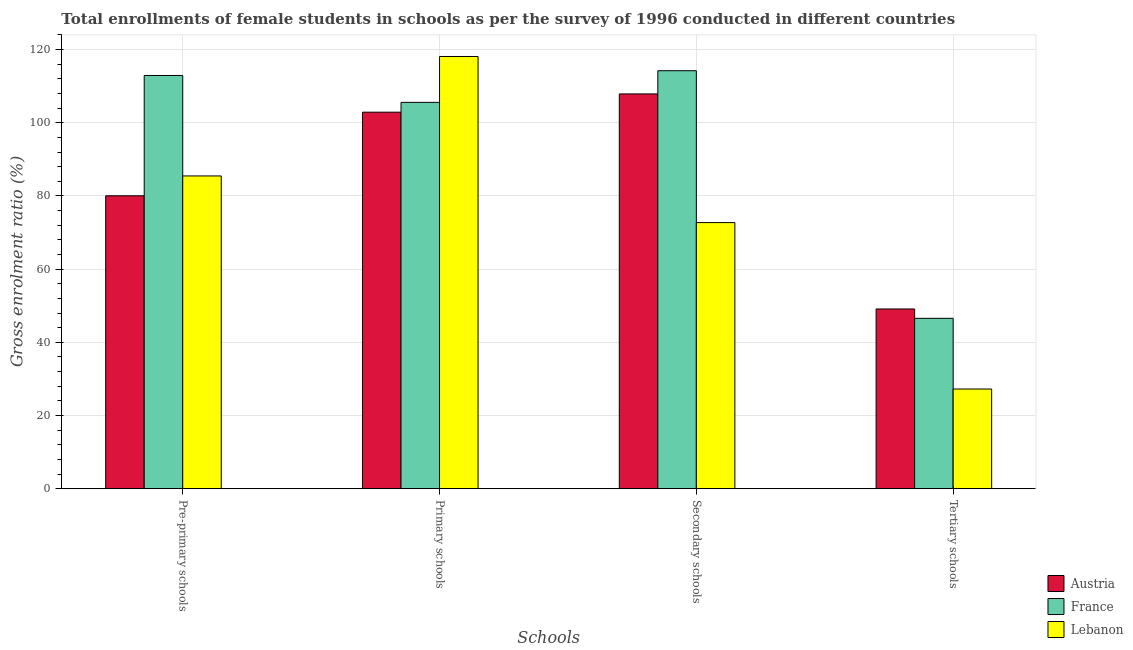How many different coloured bars are there?
Your answer should be compact. 3. What is the label of the 2nd group of bars from the left?
Provide a short and direct response. Primary schools. What is the gross enrolment ratio(female) in primary schools in France?
Offer a terse response. 105.58. Across all countries, what is the maximum gross enrolment ratio(female) in secondary schools?
Offer a terse response. 114.23. Across all countries, what is the minimum gross enrolment ratio(female) in secondary schools?
Your answer should be very brief. 72.72. In which country was the gross enrolment ratio(female) in tertiary schools minimum?
Keep it short and to the point. Lebanon. What is the total gross enrolment ratio(female) in tertiary schools in the graph?
Offer a terse response. 122.92. What is the difference between the gross enrolment ratio(female) in secondary schools in France and that in Lebanon?
Offer a terse response. 41.51. What is the difference between the gross enrolment ratio(female) in primary schools in Austria and the gross enrolment ratio(female) in secondary schools in France?
Provide a short and direct response. -11.33. What is the average gross enrolment ratio(female) in tertiary schools per country?
Offer a terse response. 40.97. What is the difference between the gross enrolment ratio(female) in secondary schools and gross enrolment ratio(female) in pre-primary schools in Lebanon?
Offer a very short reply. -12.75. What is the ratio of the gross enrolment ratio(female) in secondary schools in Lebanon to that in France?
Offer a very short reply. 0.64. Is the gross enrolment ratio(female) in tertiary schools in Lebanon less than that in Austria?
Make the answer very short. Yes. What is the difference between the highest and the second highest gross enrolment ratio(female) in secondary schools?
Provide a succinct answer. 6.34. What is the difference between the highest and the lowest gross enrolment ratio(female) in primary schools?
Provide a succinct answer. 15.22. In how many countries, is the gross enrolment ratio(female) in pre-primary schools greater than the average gross enrolment ratio(female) in pre-primary schools taken over all countries?
Make the answer very short. 1. Is the sum of the gross enrolment ratio(female) in pre-primary schools in France and Lebanon greater than the maximum gross enrolment ratio(female) in secondary schools across all countries?
Your answer should be compact. Yes. Is it the case that in every country, the sum of the gross enrolment ratio(female) in tertiary schools and gross enrolment ratio(female) in primary schools is greater than the sum of gross enrolment ratio(female) in secondary schools and gross enrolment ratio(female) in pre-primary schools?
Give a very brief answer. No. What does the 3rd bar from the left in Secondary schools represents?
Give a very brief answer. Lebanon. What does the 1st bar from the right in Primary schools represents?
Make the answer very short. Lebanon. How many bars are there?
Make the answer very short. 12. Are all the bars in the graph horizontal?
Your answer should be compact. No. How many countries are there in the graph?
Keep it short and to the point. 3. Are the values on the major ticks of Y-axis written in scientific E-notation?
Ensure brevity in your answer.  No. Where does the legend appear in the graph?
Your response must be concise. Bottom right. How many legend labels are there?
Give a very brief answer. 3. How are the legend labels stacked?
Your response must be concise. Vertical. What is the title of the graph?
Provide a short and direct response. Total enrollments of female students in schools as per the survey of 1996 conducted in different countries. What is the label or title of the X-axis?
Your answer should be compact. Schools. What is the label or title of the Y-axis?
Provide a succinct answer. Gross enrolment ratio (%). What is the Gross enrolment ratio (%) in Austria in Pre-primary schools?
Give a very brief answer. 80.05. What is the Gross enrolment ratio (%) in France in Pre-primary schools?
Give a very brief answer. 112.93. What is the Gross enrolment ratio (%) of Lebanon in Pre-primary schools?
Your response must be concise. 85.47. What is the Gross enrolment ratio (%) of Austria in Primary schools?
Ensure brevity in your answer.  102.9. What is the Gross enrolment ratio (%) of France in Primary schools?
Make the answer very short. 105.58. What is the Gross enrolment ratio (%) of Lebanon in Primary schools?
Give a very brief answer. 118.12. What is the Gross enrolment ratio (%) of Austria in Secondary schools?
Ensure brevity in your answer.  107.89. What is the Gross enrolment ratio (%) in France in Secondary schools?
Your response must be concise. 114.23. What is the Gross enrolment ratio (%) of Lebanon in Secondary schools?
Provide a succinct answer. 72.72. What is the Gross enrolment ratio (%) in Austria in Tertiary schools?
Make the answer very short. 49.12. What is the Gross enrolment ratio (%) of France in Tertiary schools?
Offer a very short reply. 46.56. What is the Gross enrolment ratio (%) in Lebanon in Tertiary schools?
Ensure brevity in your answer.  27.24. Across all Schools, what is the maximum Gross enrolment ratio (%) in Austria?
Give a very brief answer. 107.89. Across all Schools, what is the maximum Gross enrolment ratio (%) of France?
Make the answer very short. 114.23. Across all Schools, what is the maximum Gross enrolment ratio (%) in Lebanon?
Give a very brief answer. 118.12. Across all Schools, what is the minimum Gross enrolment ratio (%) in Austria?
Make the answer very short. 49.12. Across all Schools, what is the minimum Gross enrolment ratio (%) of France?
Your response must be concise. 46.56. Across all Schools, what is the minimum Gross enrolment ratio (%) in Lebanon?
Keep it short and to the point. 27.24. What is the total Gross enrolment ratio (%) of Austria in the graph?
Provide a short and direct response. 339.96. What is the total Gross enrolment ratio (%) in France in the graph?
Provide a succinct answer. 379.3. What is the total Gross enrolment ratio (%) in Lebanon in the graph?
Keep it short and to the point. 303.55. What is the difference between the Gross enrolment ratio (%) of Austria in Pre-primary schools and that in Primary schools?
Give a very brief answer. -22.85. What is the difference between the Gross enrolment ratio (%) of France in Pre-primary schools and that in Primary schools?
Offer a very short reply. 7.35. What is the difference between the Gross enrolment ratio (%) in Lebanon in Pre-primary schools and that in Primary schools?
Your response must be concise. -32.65. What is the difference between the Gross enrolment ratio (%) of Austria in Pre-primary schools and that in Secondary schools?
Make the answer very short. -27.84. What is the difference between the Gross enrolment ratio (%) in France in Pre-primary schools and that in Secondary schools?
Give a very brief answer. -1.3. What is the difference between the Gross enrolment ratio (%) of Lebanon in Pre-primary schools and that in Secondary schools?
Offer a terse response. 12.75. What is the difference between the Gross enrolment ratio (%) in Austria in Pre-primary schools and that in Tertiary schools?
Keep it short and to the point. 30.93. What is the difference between the Gross enrolment ratio (%) in France in Pre-primary schools and that in Tertiary schools?
Provide a short and direct response. 66.37. What is the difference between the Gross enrolment ratio (%) of Lebanon in Pre-primary schools and that in Tertiary schools?
Make the answer very short. 58.23. What is the difference between the Gross enrolment ratio (%) in Austria in Primary schools and that in Secondary schools?
Your answer should be compact. -4.99. What is the difference between the Gross enrolment ratio (%) of France in Primary schools and that in Secondary schools?
Ensure brevity in your answer.  -8.65. What is the difference between the Gross enrolment ratio (%) in Lebanon in Primary schools and that in Secondary schools?
Provide a succinct answer. 45.4. What is the difference between the Gross enrolment ratio (%) in Austria in Primary schools and that in Tertiary schools?
Provide a succinct answer. 53.79. What is the difference between the Gross enrolment ratio (%) of France in Primary schools and that in Tertiary schools?
Ensure brevity in your answer.  59.02. What is the difference between the Gross enrolment ratio (%) of Lebanon in Primary schools and that in Tertiary schools?
Ensure brevity in your answer.  90.88. What is the difference between the Gross enrolment ratio (%) in Austria in Secondary schools and that in Tertiary schools?
Your response must be concise. 58.77. What is the difference between the Gross enrolment ratio (%) in France in Secondary schools and that in Tertiary schools?
Provide a short and direct response. 67.67. What is the difference between the Gross enrolment ratio (%) of Lebanon in Secondary schools and that in Tertiary schools?
Provide a short and direct response. 45.48. What is the difference between the Gross enrolment ratio (%) of Austria in Pre-primary schools and the Gross enrolment ratio (%) of France in Primary schools?
Your answer should be compact. -25.53. What is the difference between the Gross enrolment ratio (%) of Austria in Pre-primary schools and the Gross enrolment ratio (%) of Lebanon in Primary schools?
Offer a terse response. -38.07. What is the difference between the Gross enrolment ratio (%) of France in Pre-primary schools and the Gross enrolment ratio (%) of Lebanon in Primary schools?
Offer a terse response. -5.19. What is the difference between the Gross enrolment ratio (%) of Austria in Pre-primary schools and the Gross enrolment ratio (%) of France in Secondary schools?
Give a very brief answer. -34.18. What is the difference between the Gross enrolment ratio (%) of Austria in Pre-primary schools and the Gross enrolment ratio (%) of Lebanon in Secondary schools?
Your response must be concise. 7.33. What is the difference between the Gross enrolment ratio (%) in France in Pre-primary schools and the Gross enrolment ratio (%) in Lebanon in Secondary schools?
Offer a terse response. 40.21. What is the difference between the Gross enrolment ratio (%) of Austria in Pre-primary schools and the Gross enrolment ratio (%) of France in Tertiary schools?
Provide a short and direct response. 33.49. What is the difference between the Gross enrolment ratio (%) of Austria in Pre-primary schools and the Gross enrolment ratio (%) of Lebanon in Tertiary schools?
Provide a succinct answer. 52.81. What is the difference between the Gross enrolment ratio (%) of France in Pre-primary schools and the Gross enrolment ratio (%) of Lebanon in Tertiary schools?
Make the answer very short. 85.69. What is the difference between the Gross enrolment ratio (%) in Austria in Primary schools and the Gross enrolment ratio (%) in France in Secondary schools?
Provide a succinct answer. -11.33. What is the difference between the Gross enrolment ratio (%) of Austria in Primary schools and the Gross enrolment ratio (%) of Lebanon in Secondary schools?
Provide a short and direct response. 30.18. What is the difference between the Gross enrolment ratio (%) of France in Primary schools and the Gross enrolment ratio (%) of Lebanon in Secondary schools?
Keep it short and to the point. 32.86. What is the difference between the Gross enrolment ratio (%) of Austria in Primary schools and the Gross enrolment ratio (%) of France in Tertiary schools?
Offer a terse response. 56.34. What is the difference between the Gross enrolment ratio (%) in Austria in Primary schools and the Gross enrolment ratio (%) in Lebanon in Tertiary schools?
Your answer should be very brief. 75.66. What is the difference between the Gross enrolment ratio (%) of France in Primary schools and the Gross enrolment ratio (%) of Lebanon in Tertiary schools?
Ensure brevity in your answer.  78.34. What is the difference between the Gross enrolment ratio (%) of Austria in Secondary schools and the Gross enrolment ratio (%) of France in Tertiary schools?
Keep it short and to the point. 61.33. What is the difference between the Gross enrolment ratio (%) of Austria in Secondary schools and the Gross enrolment ratio (%) of Lebanon in Tertiary schools?
Offer a very short reply. 80.65. What is the difference between the Gross enrolment ratio (%) of France in Secondary schools and the Gross enrolment ratio (%) of Lebanon in Tertiary schools?
Make the answer very short. 86.99. What is the average Gross enrolment ratio (%) in Austria per Schools?
Keep it short and to the point. 84.99. What is the average Gross enrolment ratio (%) in France per Schools?
Your response must be concise. 94.83. What is the average Gross enrolment ratio (%) of Lebanon per Schools?
Make the answer very short. 75.89. What is the difference between the Gross enrolment ratio (%) in Austria and Gross enrolment ratio (%) in France in Pre-primary schools?
Offer a very short reply. -32.88. What is the difference between the Gross enrolment ratio (%) of Austria and Gross enrolment ratio (%) of Lebanon in Pre-primary schools?
Your answer should be very brief. -5.42. What is the difference between the Gross enrolment ratio (%) in France and Gross enrolment ratio (%) in Lebanon in Pre-primary schools?
Ensure brevity in your answer.  27.46. What is the difference between the Gross enrolment ratio (%) in Austria and Gross enrolment ratio (%) in France in Primary schools?
Your response must be concise. -2.68. What is the difference between the Gross enrolment ratio (%) in Austria and Gross enrolment ratio (%) in Lebanon in Primary schools?
Provide a succinct answer. -15.22. What is the difference between the Gross enrolment ratio (%) of France and Gross enrolment ratio (%) of Lebanon in Primary schools?
Offer a very short reply. -12.54. What is the difference between the Gross enrolment ratio (%) in Austria and Gross enrolment ratio (%) in France in Secondary schools?
Offer a terse response. -6.34. What is the difference between the Gross enrolment ratio (%) of Austria and Gross enrolment ratio (%) of Lebanon in Secondary schools?
Your response must be concise. 35.17. What is the difference between the Gross enrolment ratio (%) of France and Gross enrolment ratio (%) of Lebanon in Secondary schools?
Your answer should be very brief. 41.51. What is the difference between the Gross enrolment ratio (%) in Austria and Gross enrolment ratio (%) in France in Tertiary schools?
Offer a very short reply. 2.56. What is the difference between the Gross enrolment ratio (%) of Austria and Gross enrolment ratio (%) of Lebanon in Tertiary schools?
Offer a very short reply. 21.88. What is the difference between the Gross enrolment ratio (%) of France and Gross enrolment ratio (%) of Lebanon in Tertiary schools?
Offer a very short reply. 19.32. What is the ratio of the Gross enrolment ratio (%) of Austria in Pre-primary schools to that in Primary schools?
Your response must be concise. 0.78. What is the ratio of the Gross enrolment ratio (%) of France in Pre-primary schools to that in Primary schools?
Offer a very short reply. 1.07. What is the ratio of the Gross enrolment ratio (%) in Lebanon in Pre-primary schools to that in Primary schools?
Ensure brevity in your answer.  0.72. What is the ratio of the Gross enrolment ratio (%) in Austria in Pre-primary schools to that in Secondary schools?
Your answer should be very brief. 0.74. What is the ratio of the Gross enrolment ratio (%) in France in Pre-primary schools to that in Secondary schools?
Provide a short and direct response. 0.99. What is the ratio of the Gross enrolment ratio (%) in Lebanon in Pre-primary schools to that in Secondary schools?
Ensure brevity in your answer.  1.18. What is the ratio of the Gross enrolment ratio (%) of Austria in Pre-primary schools to that in Tertiary schools?
Provide a succinct answer. 1.63. What is the ratio of the Gross enrolment ratio (%) of France in Pre-primary schools to that in Tertiary schools?
Ensure brevity in your answer.  2.43. What is the ratio of the Gross enrolment ratio (%) of Lebanon in Pre-primary schools to that in Tertiary schools?
Provide a short and direct response. 3.14. What is the ratio of the Gross enrolment ratio (%) of Austria in Primary schools to that in Secondary schools?
Your answer should be very brief. 0.95. What is the ratio of the Gross enrolment ratio (%) in France in Primary schools to that in Secondary schools?
Provide a succinct answer. 0.92. What is the ratio of the Gross enrolment ratio (%) of Lebanon in Primary schools to that in Secondary schools?
Give a very brief answer. 1.62. What is the ratio of the Gross enrolment ratio (%) in Austria in Primary schools to that in Tertiary schools?
Give a very brief answer. 2.1. What is the ratio of the Gross enrolment ratio (%) of France in Primary schools to that in Tertiary schools?
Keep it short and to the point. 2.27. What is the ratio of the Gross enrolment ratio (%) of Lebanon in Primary schools to that in Tertiary schools?
Make the answer very short. 4.34. What is the ratio of the Gross enrolment ratio (%) in Austria in Secondary schools to that in Tertiary schools?
Keep it short and to the point. 2.2. What is the ratio of the Gross enrolment ratio (%) in France in Secondary schools to that in Tertiary schools?
Offer a terse response. 2.45. What is the ratio of the Gross enrolment ratio (%) of Lebanon in Secondary schools to that in Tertiary schools?
Your answer should be compact. 2.67. What is the difference between the highest and the second highest Gross enrolment ratio (%) in Austria?
Your response must be concise. 4.99. What is the difference between the highest and the second highest Gross enrolment ratio (%) in France?
Make the answer very short. 1.3. What is the difference between the highest and the second highest Gross enrolment ratio (%) of Lebanon?
Your answer should be very brief. 32.65. What is the difference between the highest and the lowest Gross enrolment ratio (%) in Austria?
Provide a succinct answer. 58.77. What is the difference between the highest and the lowest Gross enrolment ratio (%) of France?
Offer a terse response. 67.67. What is the difference between the highest and the lowest Gross enrolment ratio (%) in Lebanon?
Offer a very short reply. 90.88. 